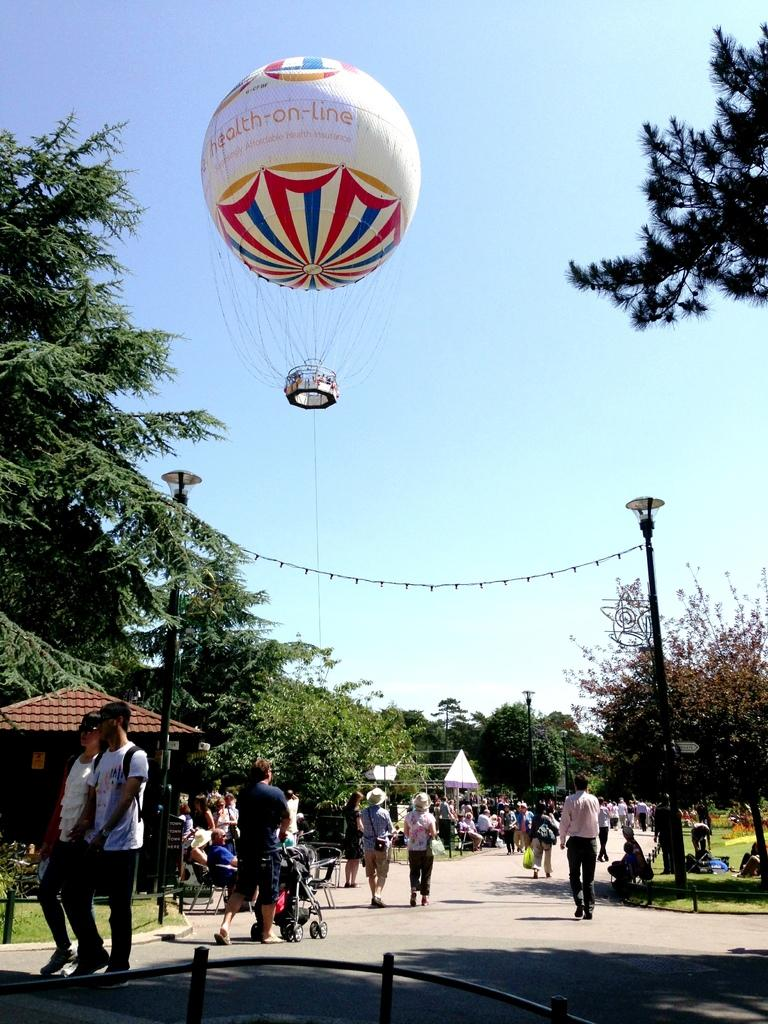What are the people in the image doing? There are persons walking and sitting in the center of the image. What type of natural elements can be seen in the image? There are trees in the image. What are the vertical structures in the image? There are poles in the image. What is floating in the sky in the image? There is a balloon in the sky. What type of temporary shelter is present in the image? There are tents in the image. What type of wealth is being displayed on a plate in the image? There is no plate or wealth present in the image. What type of connection can be seen between the persons in the image? The image does not show any specific connections between the persons; they are simply walking and sitting. 